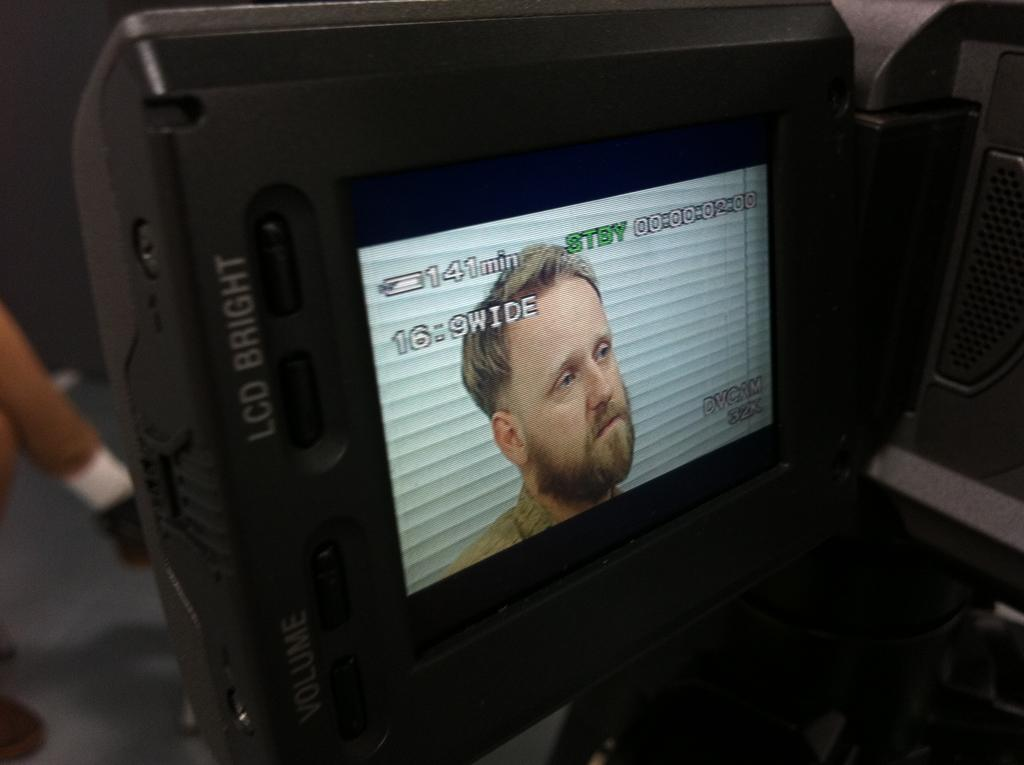What is the main object in the center of the image? There is a monitor in the center of the image. What can be seen on the monitor's screen? A person is visible on the monitor's screen. How would you describe the background of the image? The background of the image is blurred. What can be found on the right side of the image? There is an object on the right side of the image. What type of jeans is the person wearing while teaching in the image? There is no person wearing jeans or teaching in the image; the main subject is a monitor with a person visible on its screen. 